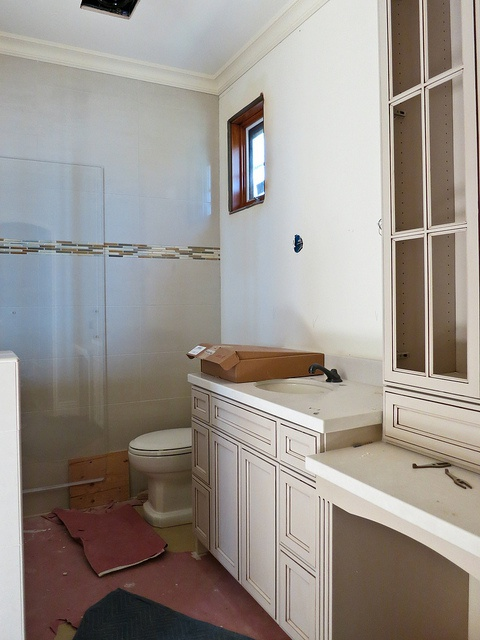Describe the objects in this image and their specific colors. I can see toilet in darkgray, gray, and black tones and sink in darkgray and gray tones in this image. 